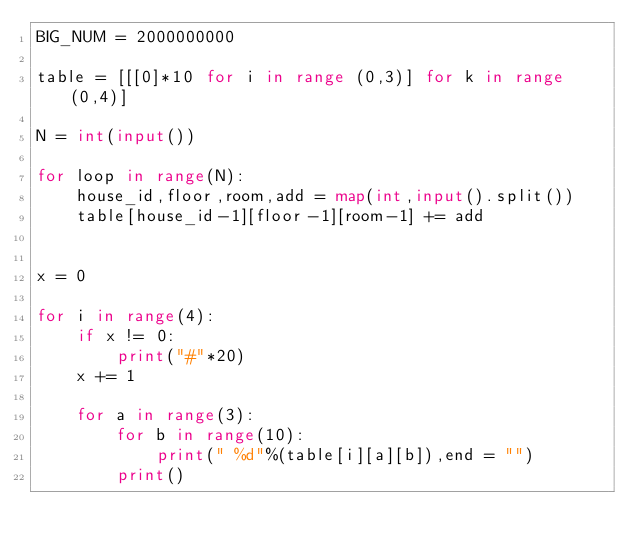<code> <loc_0><loc_0><loc_500><loc_500><_Python_>BIG_NUM = 2000000000

table = [[[0]*10 for i in range (0,3)] for k in range (0,4)]

N = int(input())

for loop in range(N):
    house_id,floor,room,add = map(int,input().split())
    table[house_id-1][floor-1][room-1] += add


x = 0

for i in range(4):
    if x != 0:
        print("#"*20)
    x += 1

    for a in range(3):
        for b in range(10):
            print(" %d"%(table[i][a][b]),end = "")
        print()

</code> 